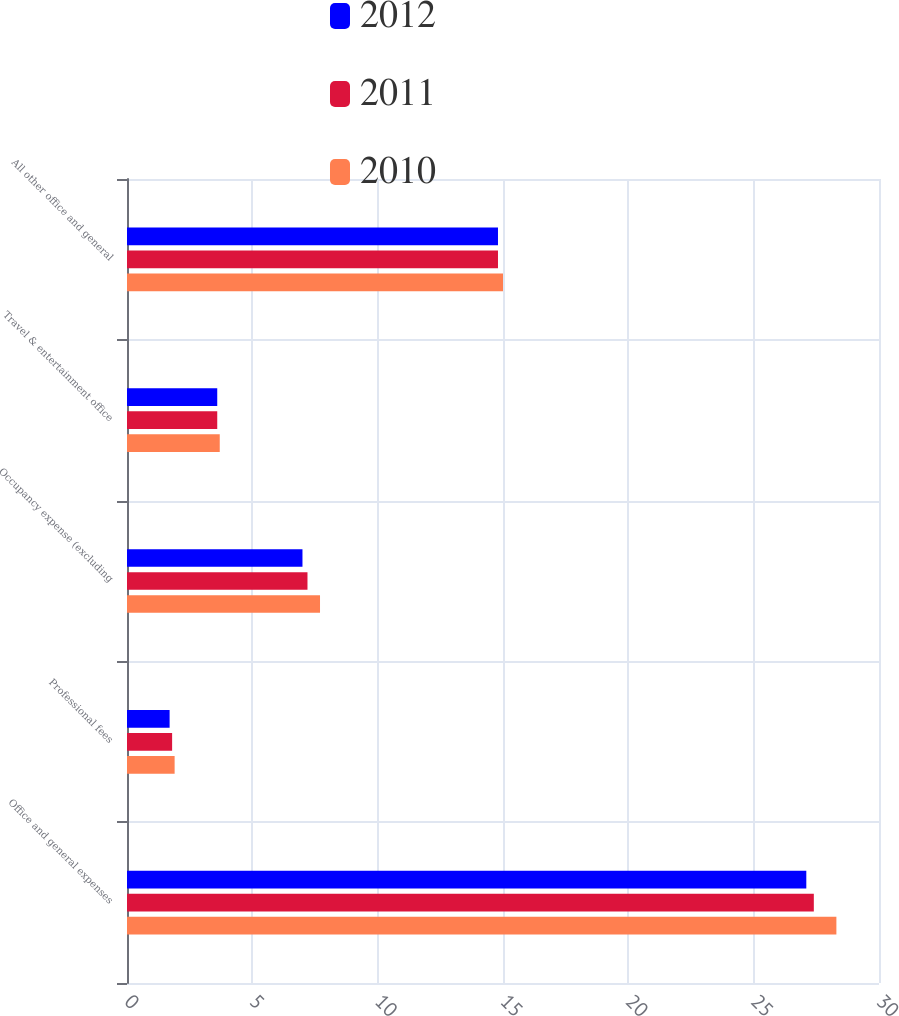Convert chart. <chart><loc_0><loc_0><loc_500><loc_500><stacked_bar_chart><ecel><fcel>Office and general expenses<fcel>Professional fees<fcel>Occupancy expense (excluding<fcel>Travel & entertainment office<fcel>All other office and general<nl><fcel>2012<fcel>27.1<fcel>1.7<fcel>7<fcel>3.6<fcel>14.8<nl><fcel>2011<fcel>27.4<fcel>1.8<fcel>7.2<fcel>3.6<fcel>14.8<nl><fcel>2010<fcel>28.3<fcel>1.9<fcel>7.7<fcel>3.7<fcel>15<nl></chart> 